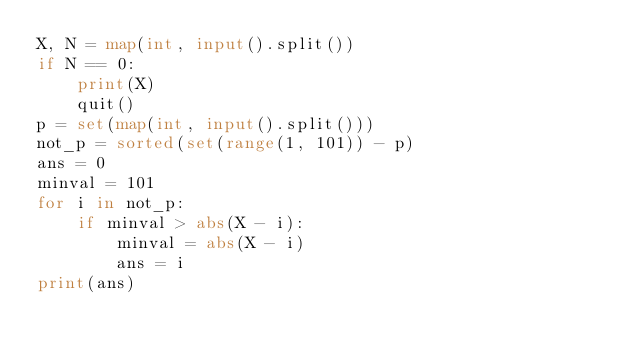Convert code to text. <code><loc_0><loc_0><loc_500><loc_500><_Python_>X, N = map(int, input().split())
if N == 0:
    print(X)
    quit()
p = set(map(int, input().split()))
not_p = sorted(set(range(1, 101)) - p)
ans = 0
minval = 101
for i in not_p:
    if minval > abs(X - i):
        minval = abs(X - i)
        ans = i
print(ans)
</code> 